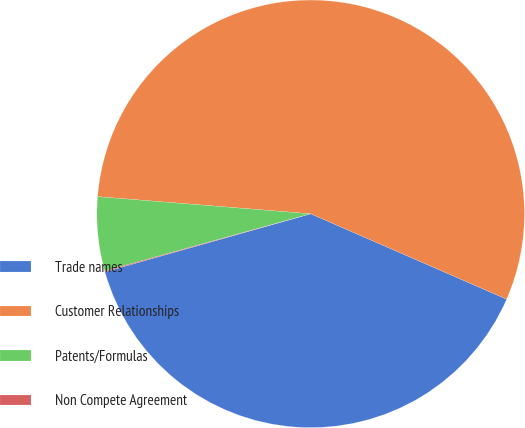<chart> <loc_0><loc_0><loc_500><loc_500><pie_chart><fcel>Trade names<fcel>Customer Relationships<fcel>Patents/Formulas<fcel>Non Compete Agreement<nl><fcel>39.08%<fcel>55.26%<fcel>5.59%<fcel>0.07%<nl></chart> 